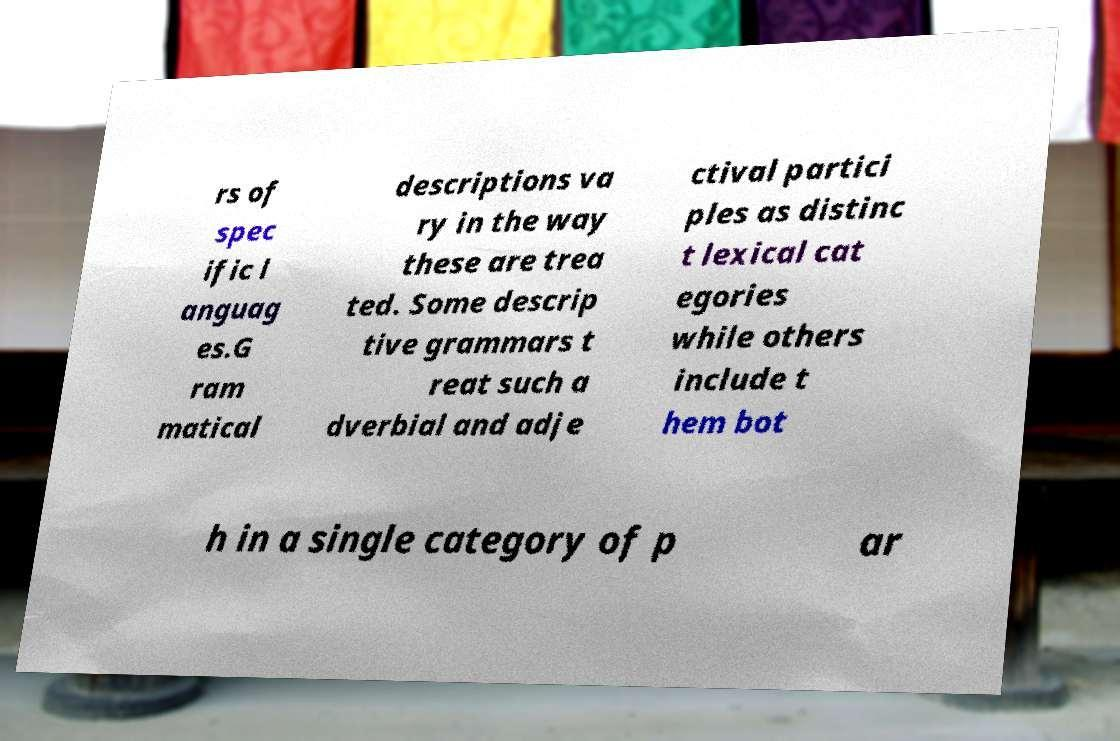Could you assist in decoding the text presented in this image and type it out clearly? rs of spec ific l anguag es.G ram matical descriptions va ry in the way these are trea ted. Some descrip tive grammars t reat such a dverbial and adje ctival partici ples as distinc t lexical cat egories while others include t hem bot h in a single category of p ar 